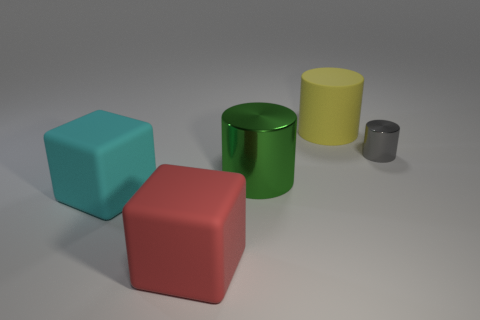There is a big thing that is in front of the big block that is behind the block that is right of the cyan rubber cube; what is its shape?
Provide a short and direct response. Cube. The big object that is both behind the large cyan block and left of the large yellow thing is made of what material?
Provide a succinct answer. Metal. What color is the matte block that is behind the matte block right of the big cube that is behind the red rubber object?
Your answer should be compact. Cyan. How many cyan things are either large matte cubes or tiny things?
Ensure brevity in your answer.  1. What number of other objects are there of the same size as the gray object?
Your answer should be compact. 0. What number of objects are there?
Ensure brevity in your answer.  5. Are the tiny cylinder in front of the big yellow rubber thing and the big cylinder to the right of the green shiny cylinder made of the same material?
Ensure brevity in your answer.  No. What is the big cyan object made of?
Your answer should be very brief. Rubber. What number of cubes have the same material as the yellow cylinder?
Offer a terse response. 2. How many metal things are cylinders or blocks?
Offer a very short reply. 2. 